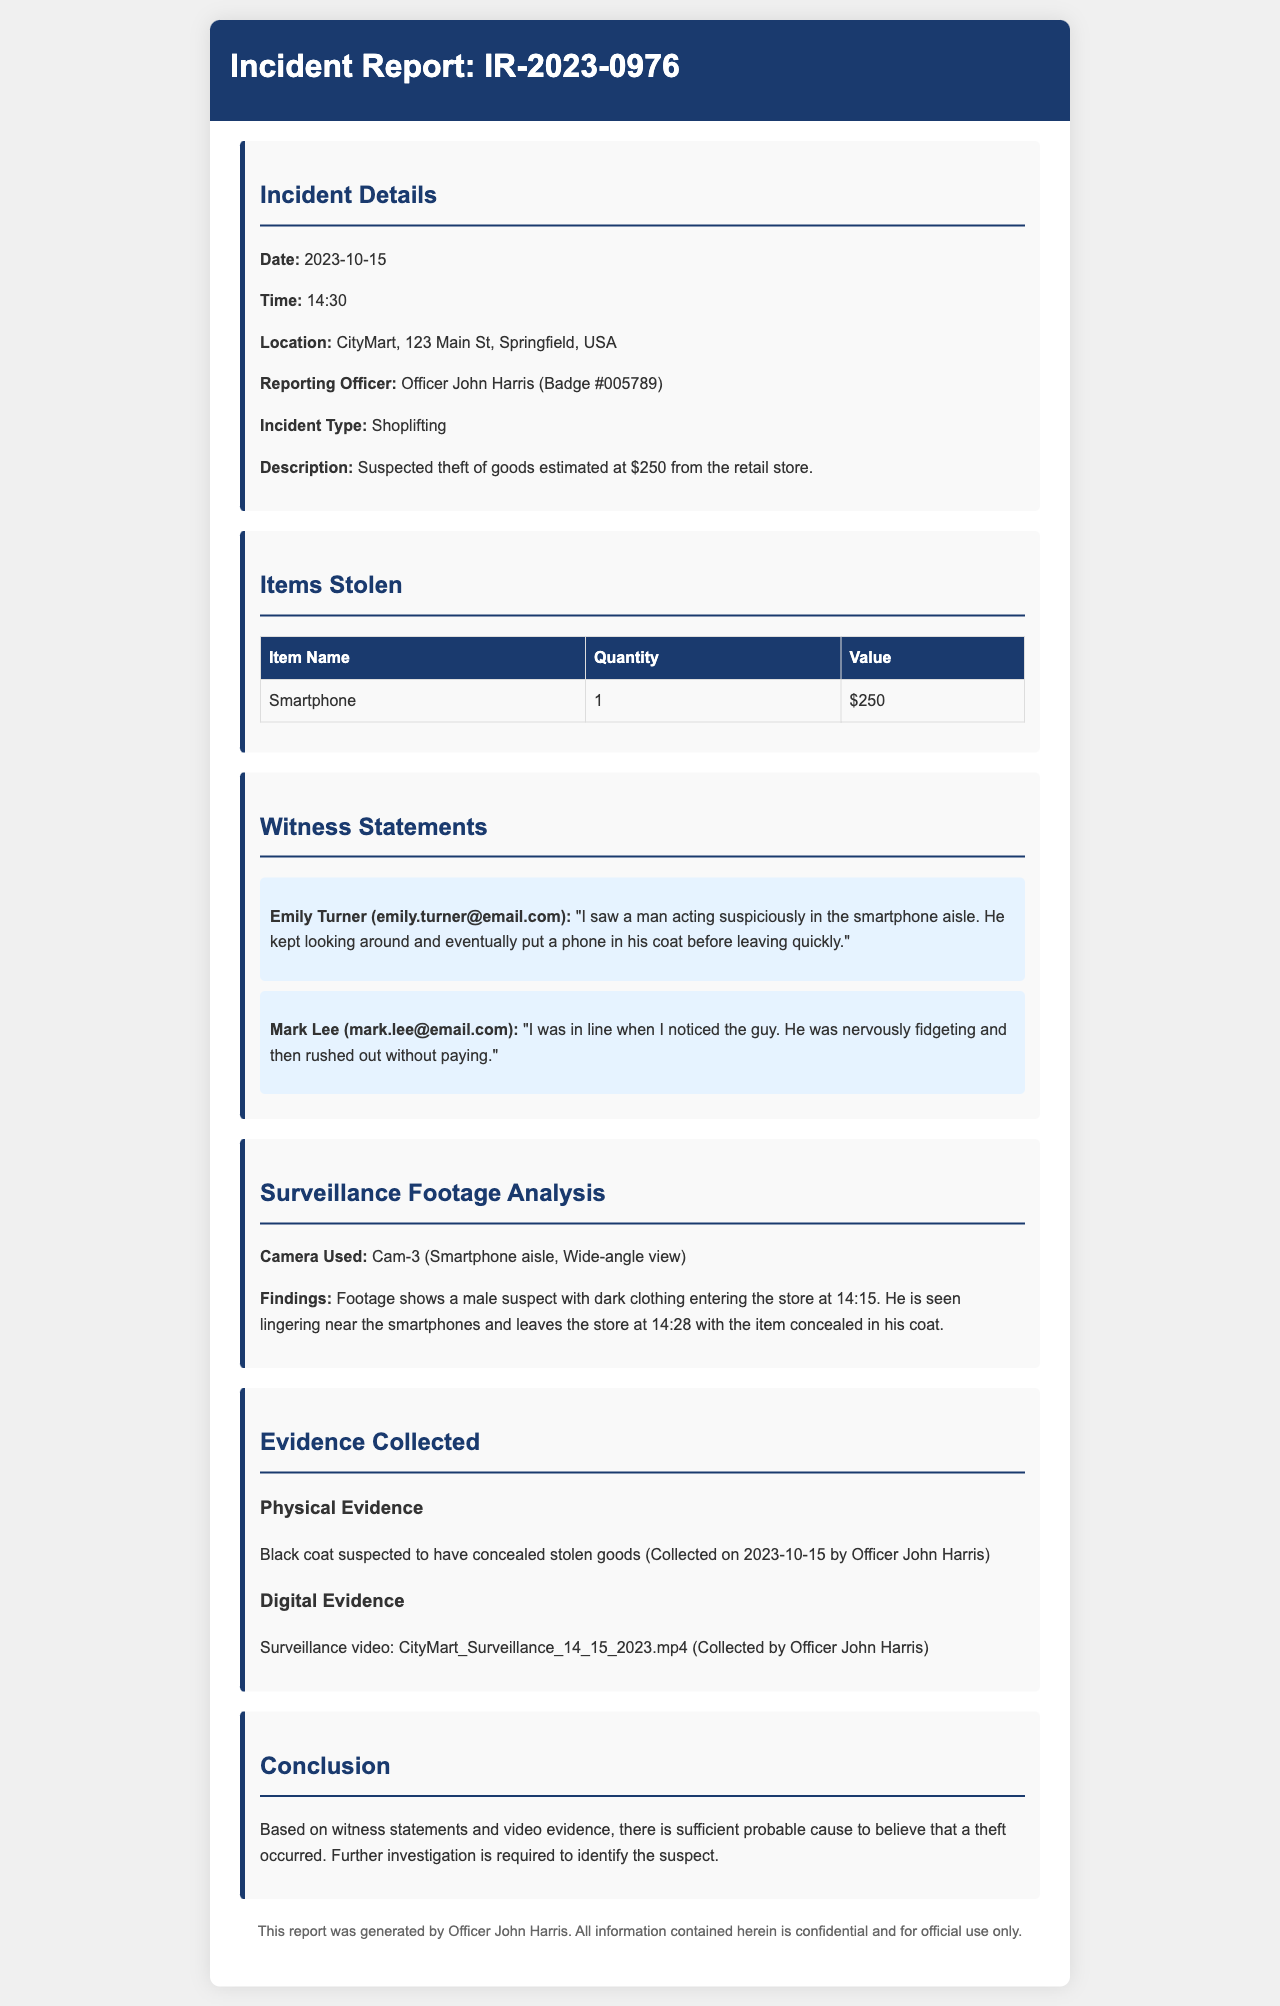what is the incident date? The incident date is clearly stated in the Incident Details section of the document as October 15, 2023.
Answer: 2023-10-15 who reported the incident? The Reporting Officer is listed in the Incident Details section, identifying Officer John Harris as the one who reported it.
Answer: Officer John Harris what items were stolen? The Items Stolen section lists the stolen goods, specifically the item name, quantity, and value.
Answer: Smartphone how much was the estimated value of goods stolen? The estimated value is mentioned alongside the item details in the Items Stolen section, specifically for the smartphone.
Answer: $250 what was found in the surveillance footage? The Surveillance Footage Analysis section describes findings regarding the suspect's behavior and actions in the store.
Answer: Male suspect with dark clothing who witnessed the event? The Witness Statements section includes names and details of individuals who observed the incident.
Answer: Emily Turner, Mark Lee what physical evidence was collected? The Evidence Collected section specifies the type of physical evidence acquired related to the case.
Answer: Black coat what time did the suspect leave the store? The time of departure is indicated in the Surveillance Footage Analysis section, which records when the suspect exited.
Answer: 14:28 what is required for further investigation? The Conclusion section summarizes what is needed moving forward concerning the case based on the evidence.
Answer: Identify the suspect 